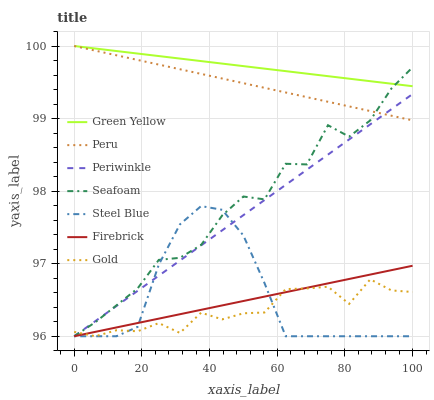Does Gold have the minimum area under the curve?
Answer yes or no. Yes. Does Green Yellow have the maximum area under the curve?
Answer yes or no. Yes. Does Firebrick have the minimum area under the curve?
Answer yes or no. No. Does Firebrick have the maximum area under the curve?
Answer yes or no. No. Is Green Yellow the smoothest?
Answer yes or no. Yes. Is Seafoam the roughest?
Answer yes or no. Yes. Is Firebrick the smoothest?
Answer yes or no. No. Is Firebrick the roughest?
Answer yes or no. No. Does Gold have the lowest value?
Answer yes or no. Yes. Does Peru have the lowest value?
Answer yes or no. No. Does Green Yellow have the highest value?
Answer yes or no. Yes. Does Firebrick have the highest value?
Answer yes or no. No. Is Steel Blue less than Green Yellow?
Answer yes or no. Yes. Is Peru greater than Firebrick?
Answer yes or no. Yes. Does Steel Blue intersect Seafoam?
Answer yes or no. Yes. Is Steel Blue less than Seafoam?
Answer yes or no. No. Is Steel Blue greater than Seafoam?
Answer yes or no. No. Does Steel Blue intersect Green Yellow?
Answer yes or no. No. 